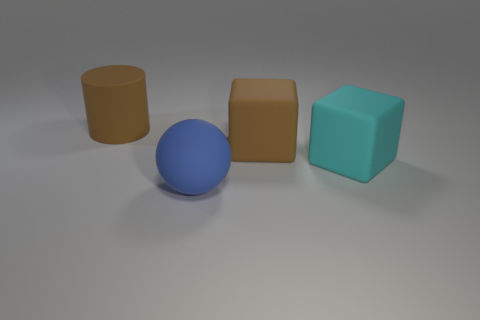Are there more small purple metallic spheres than large rubber objects?
Your answer should be very brief. No. What number of cyan cubes have the same material as the blue ball?
Ensure brevity in your answer.  1. Is the big cyan thing the same shape as the large blue thing?
Give a very brief answer. No. What is the size of the cube that is behind the cyan matte object that is behind the thing that is in front of the large cyan matte thing?
Make the answer very short. Large. Is there a big blue rubber thing to the right of the object that is on the right side of the brown rubber cube?
Make the answer very short. No. There is a brown matte object left of the brown rubber thing in front of the large matte cylinder; what number of cyan matte things are on the left side of it?
Ensure brevity in your answer.  0. What color is the big thing that is both right of the matte ball and on the left side of the large cyan object?
Offer a very short reply. Brown. How many other large cylinders have the same color as the large rubber cylinder?
Offer a very short reply. 0. What number of balls are yellow shiny objects or brown rubber objects?
Offer a very short reply. 0. What is the color of the other rubber cube that is the same size as the brown rubber block?
Offer a terse response. Cyan. 